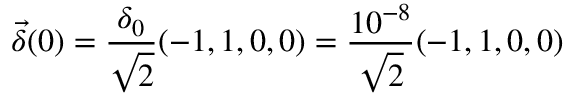<formula> <loc_0><loc_0><loc_500><loc_500>\vec { \delta } ( 0 ) = \frac { \delta _ { 0 } } { \sqrt { 2 } } ( - 1 , 1 , 0 , 0 ) = \frac { 1 0 ^ { - 8 } } { \sqrt { 2 } } ( - 1 , 1 , 0 , 0 )</formula> 